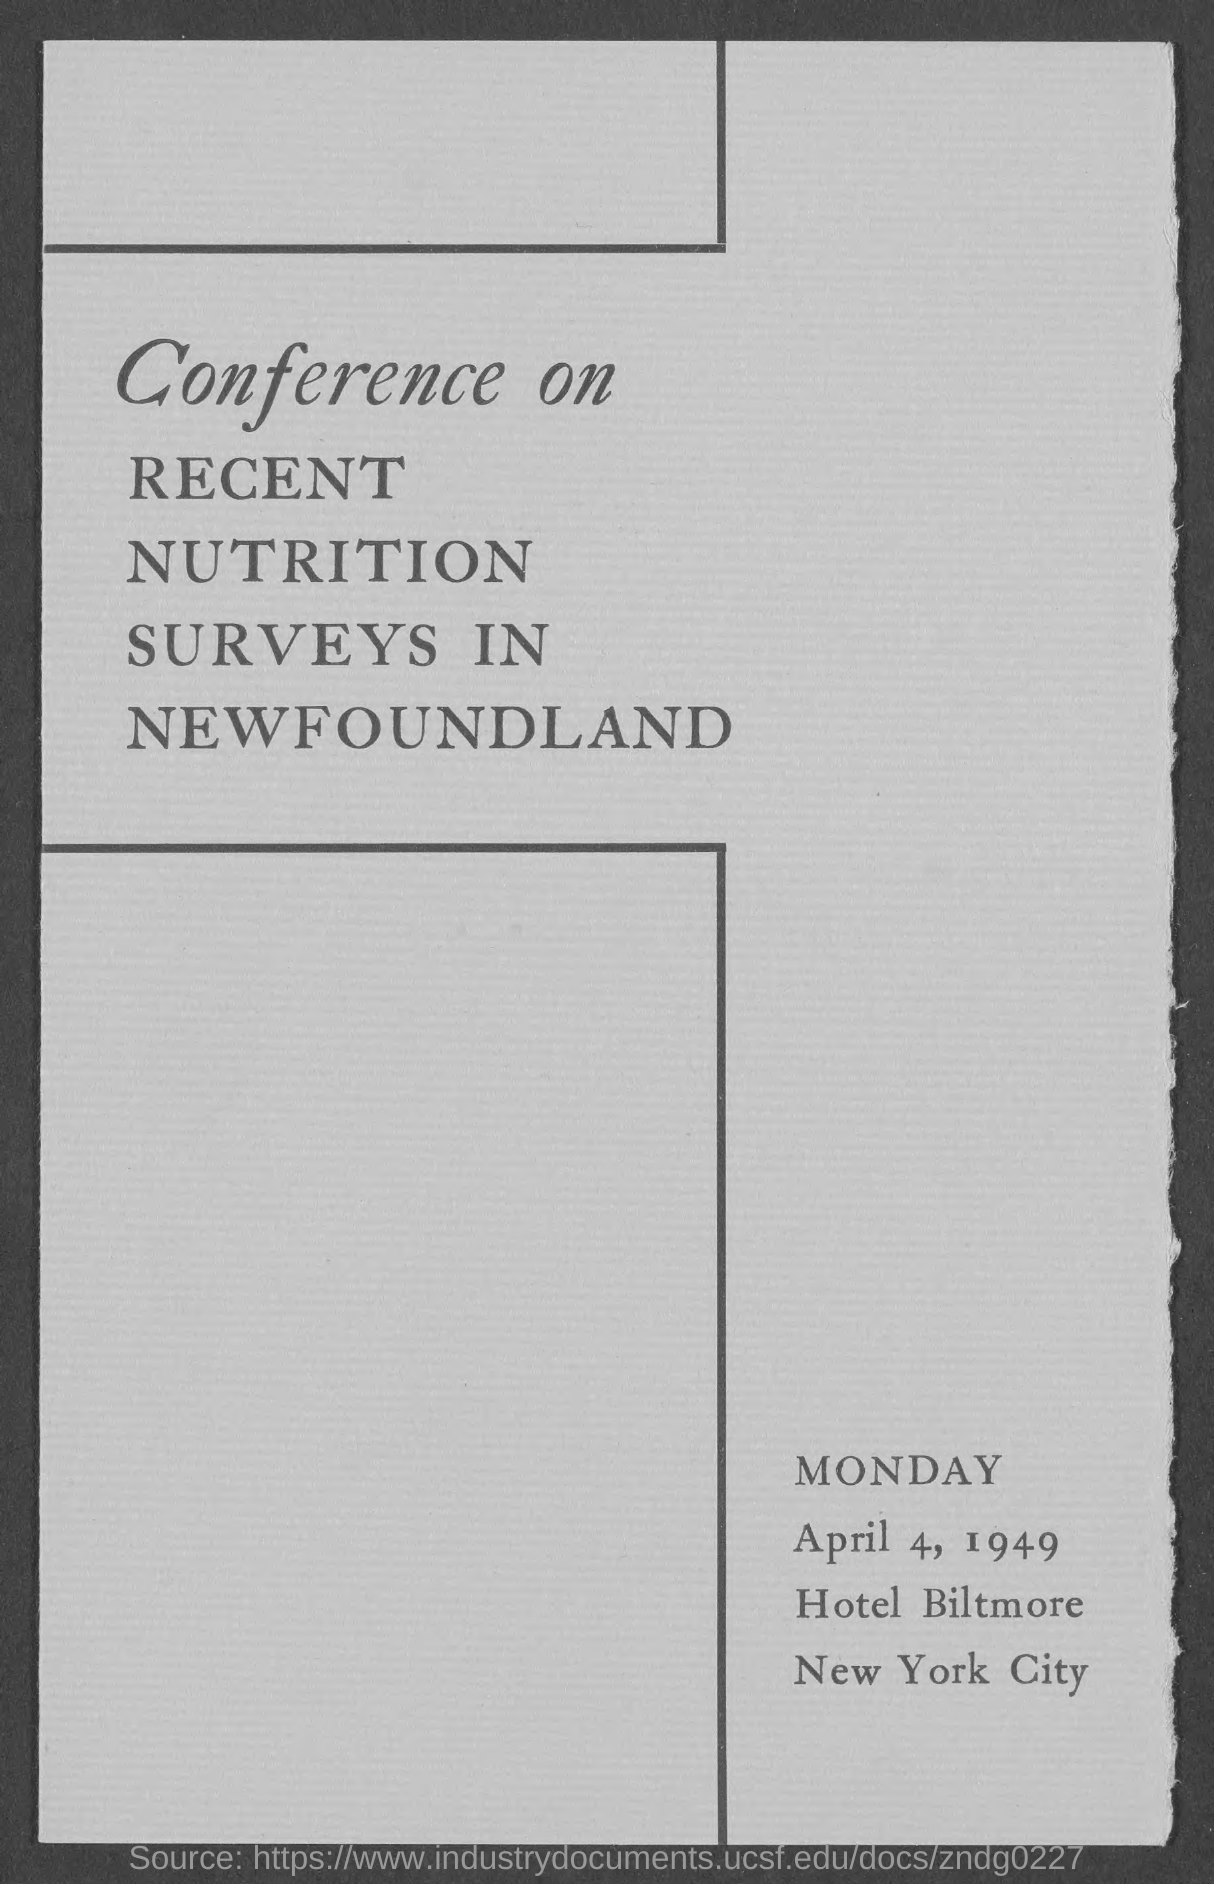What day of the week is mentioned at bottom-right side of the document ?
Ensure brevity in your answer.  Monday. 